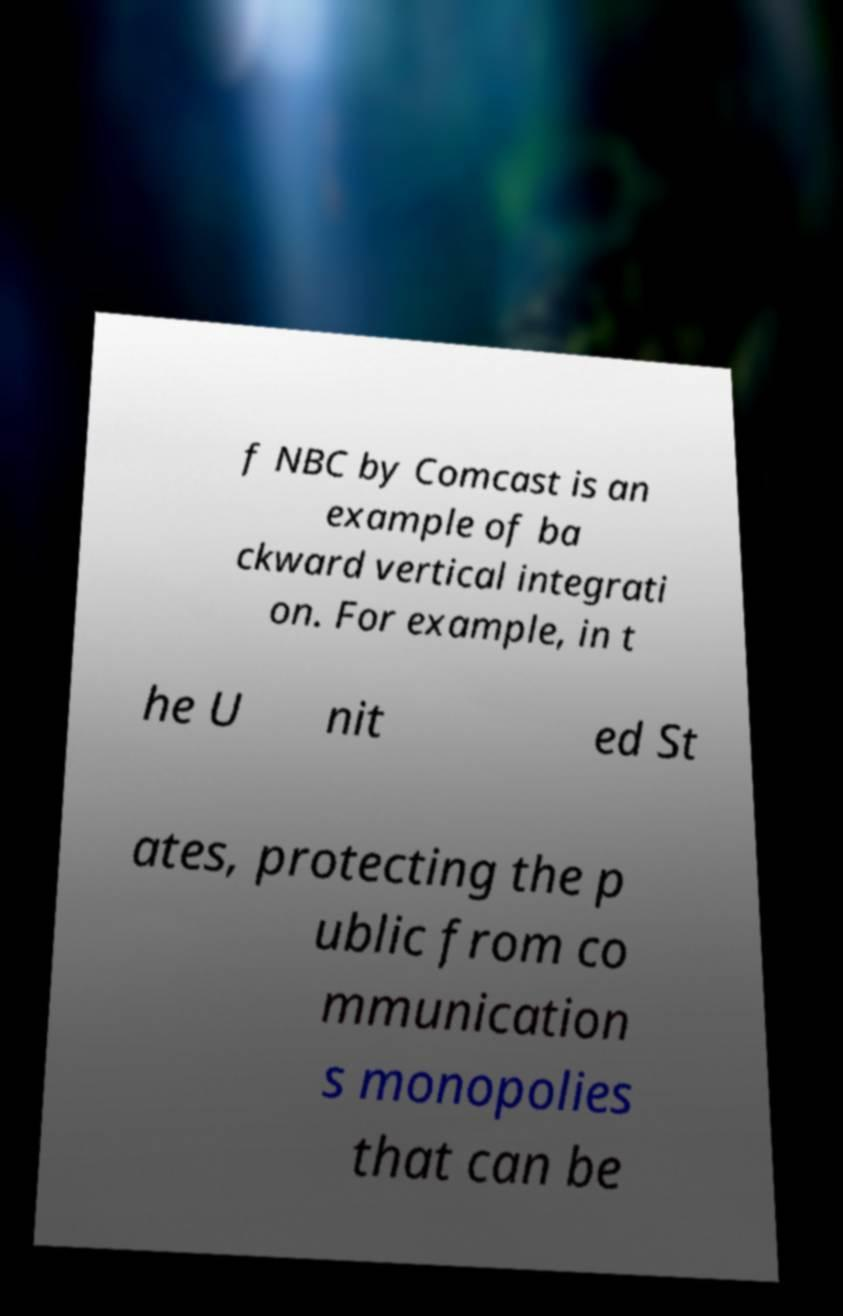What messages or text are displayed in this image? I need them in a readable, typed format. f NBC by Comcast is an example of ba ckward vertical integrati on. For example, in t he U nit ed St ates, protecting the p ublic from co mmunication s monopolies that can be 